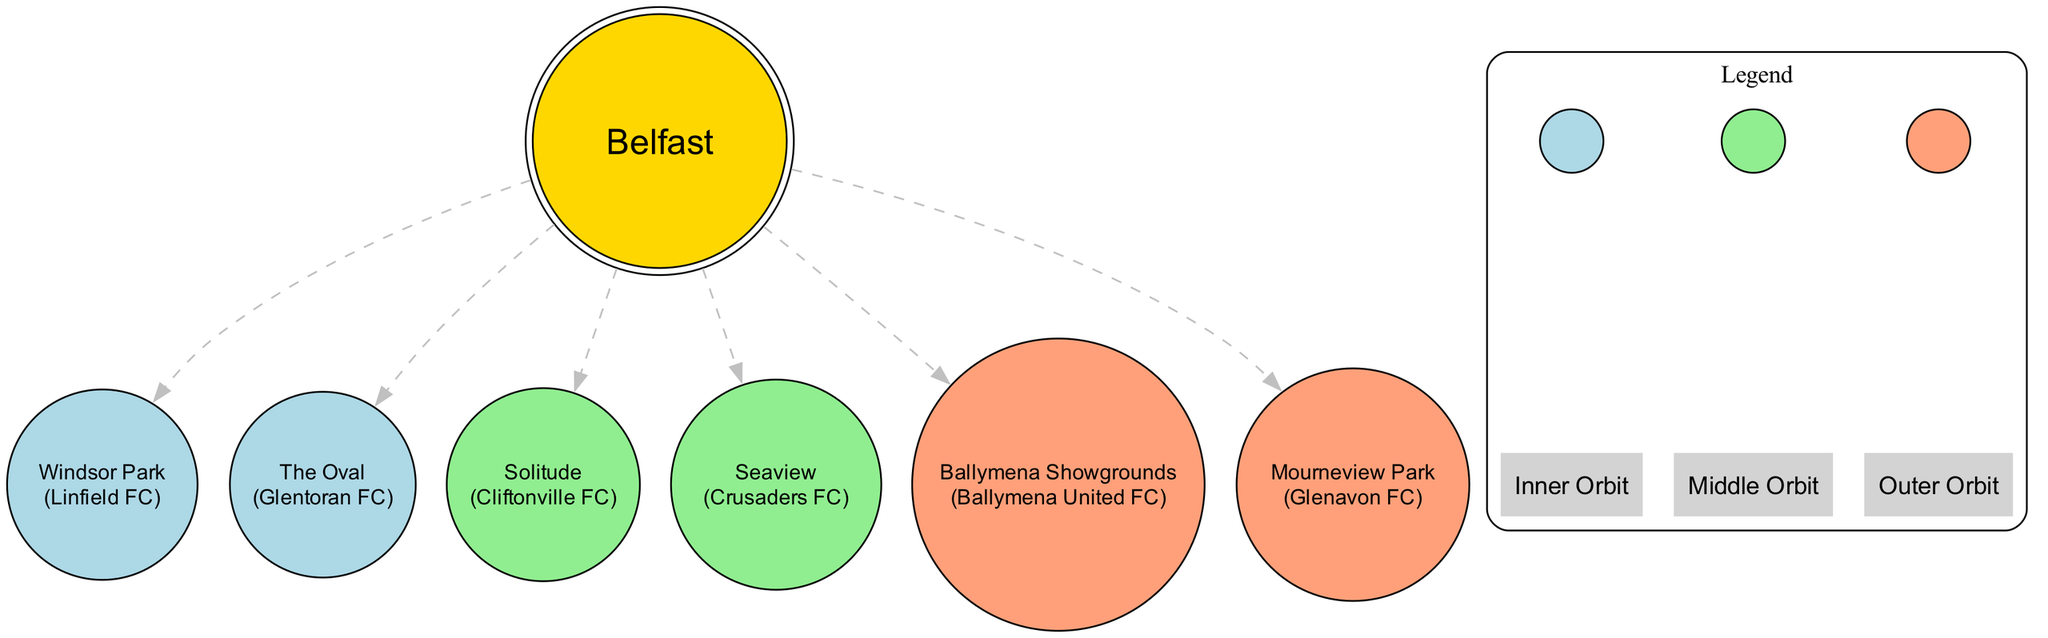What is the name of the central body in the diagram? The diagram indicates that Belfast is the central body, as it is labeled distinctly and represents the focal point for the football grounds orbiting around it.
Answer: Belfast How many football grounds are depicted in the diagram? By counting the asteroids listed, we see there are six football grounds represented in the diagram: Windsor Park, The Oval, Solitude, Seaview, Ballymena Showgrounds, and Mourneview Park.
Answer: 6 What team is associated with Windsor Park? The diagram specifies that Linfield FC is the team that corresponds to Windsor Park, which is explicitly noted next to the name of the ground in the diagram.
Answer: Linfield FC Which football grounds are in the Middle orbit? There are two football grounds listed in the Middle orbit: Solitude and Seaview. This can be seen by checking the orbital assignments for the asteroids.
Answer: Solitude, Seaview What size is the football ground at Mourneview Park? Mourneview Park is categorized as a Small football ground according to the size designation provided for this ground in the diagram.
Answer: Small Which football ground is associated with the Outer orbital zone? The diagram shows two football grounds in the Outer orbital zone: Ballymena Showgrounds and Mourneview Park, both of which are designated under the outer orbit section.
Answer: Ballymena Showgrounds, Mourneview Park How many total orbital zones are represented in the diagram? The diagram depicts three orbital zones: Belfast City, Greater Belfast, and Rural Northern Ireland, as explicitly labeled in their respective clusters.
Answer: 3 Which team plays at the largest football ground in the diagram? The largest football ground is Windsor Park, and the corresponding team playing there is Linfield FC, which is noted in the attributes of the ground in the diagram.
Answer: Linfield FC What color represents the Inner orbit in the diagram? The Inner orbit is represented by the color light blue, as indicated in the legend section of the diagram that defines the colors for each orbital zone.
Answer: Light blue 